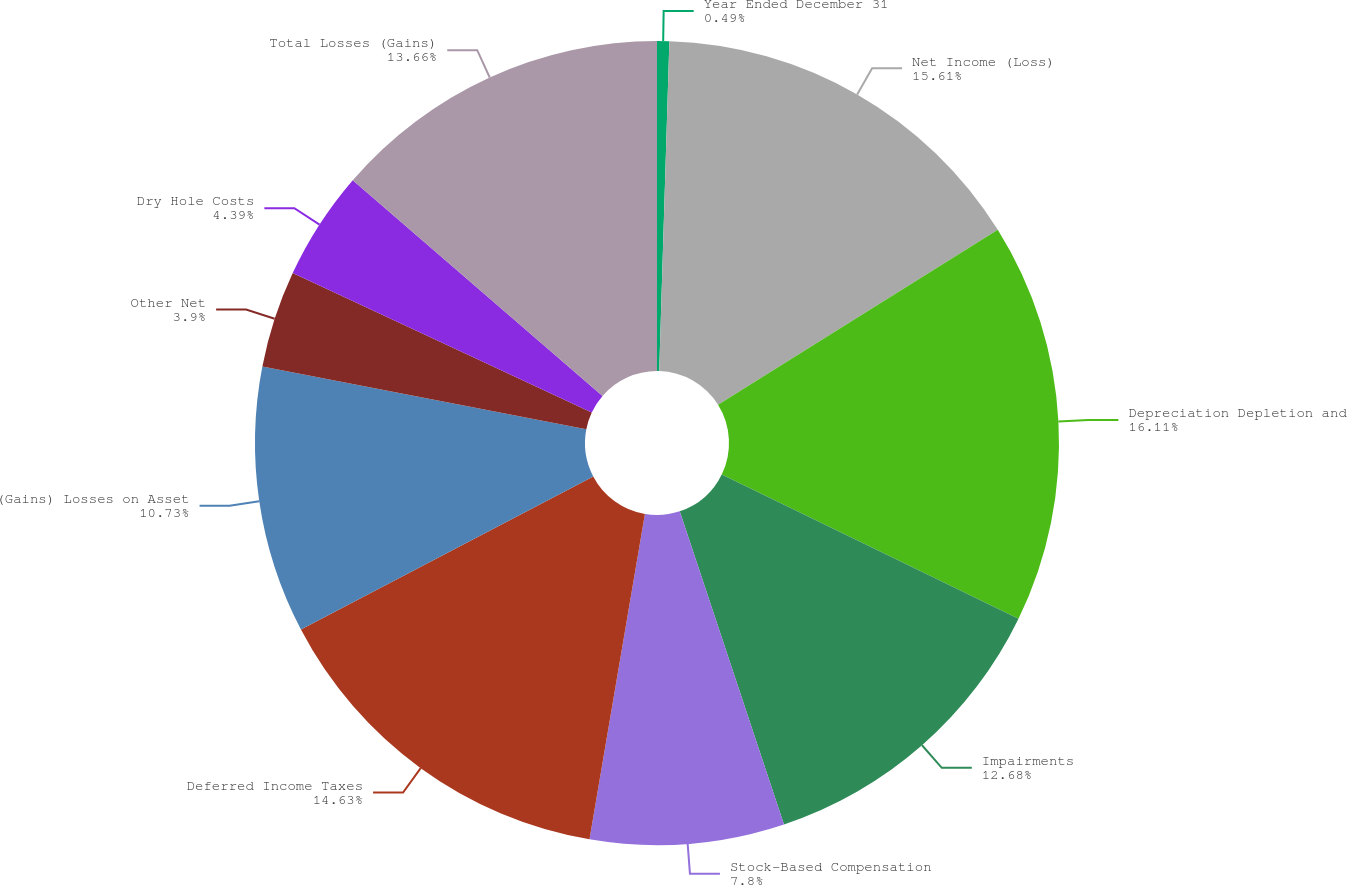Convert chart. <chart><loc_0><loc_0><loc_500><loc_500><pie_chart><fcel>Year Ended December 31<fcel>Net Income (Loss)<fcel>Depreciation Depletion and<fcel>Impairments<fcel>Stock-Based Compensation<fcel>Deferred Income Taxes<fcel>(Gains) Losses on Asset<fcel>Other Net<fcel>Dry Hole Costs<fcel>Total Losses (Gains)<nl><fcel>0.49%<fcel>15.61%<fcel>16.1%<fcel>12.68%<fcel>7.8%<fcel>14.63%<fcel>10.73%<fcel>3.9%<fcel>4.39%<fcel>13.66%<nl></chart> 